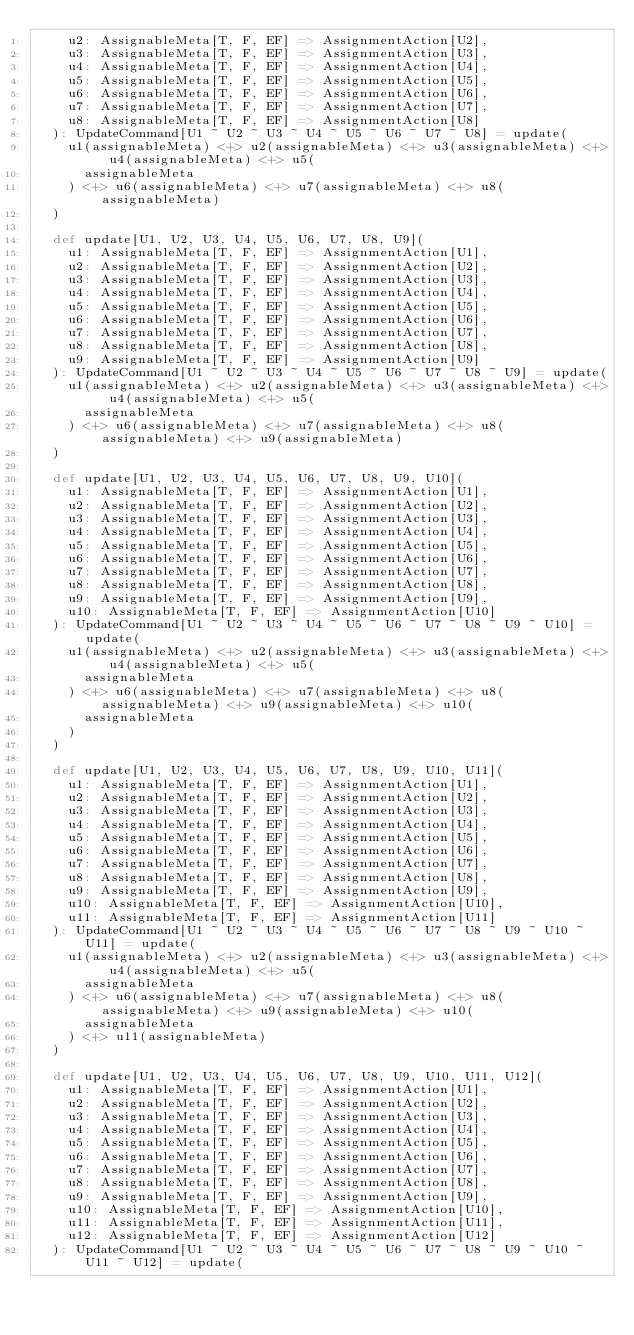Convert code to text. <code><loc_0><loc_0><loc_500><loc_500><_Scala_>    u2: AssignableMeta[T, F, EF] => AssignmentAction[U2],
    u3: AssignableMeta[T, F, EF] => AssignmentAction[U3],
    u4: AssignableMeta[T, F, EF] => AssignmentAction[U4],
    u5: AssignableMeta[T, F, EF] => AssignmentAction[U5],
    u6: AssignableMeta[T, F, EF] => AssignmentAction[U6],
    u7: AssignableMeta[T, F, EF] => AssignmentAction[U7],
    u8: AssignableMeta[T, F, EF] => AssignmentAction[U8]
  ): UpdateCommand[U1 ~ U2 ~ U3 ~ U4 ~ U5 ~ U6 ~ U7 ~ U8] = update(
    u1(assignableMeta) <+> u2(assignableMeta) <+> u3(assignableMeta) <+> u4(assignableMeta) <+> u5(
      assignableMeta
    ) <+> u6(assignableMeta) <+> u7(assignableMeta) <+> u8(assignableMeta)
  )

  def update[U1, U2, U3, U4, U5, U6, U7, U8, U9](
    u1: AssignableMeta[T, F, EF] => AssignmentAction[U1],
    u2: AssignableMeta[T, F, EF] => AssignmentAction[U2],
    u3: AssignableMeta[T, F, EF] => AssignmentAction[U3],
    u4: AssignableMeta[T, F, EF] => AssignmentAction[U4],
    u5: AssignableMeta[T, F, EF] => AssignmentAction[U5],
    u6: AssignableMeta[T, F, EF] => AssignmentAction[U6],
    u7: AssignableMeta[T, F, EF] => AssignmentAction[U7],
    u8: AssignableMeta[T, F, EF] => AssignmentAction[U8],
    u9: AssignableMeta[T, F, EF] => AssignmentAction[U9]
  ): UpdateCommand[U1 ~ U2 ~ U3 ~ U4 ~ U5 ~ U6 ~ U7 ~ U8 ~ U9] = update(
    u1(assignableMeta) <+> u2(assignableMeta) <+> u3(assignableMeta) <+> u4(assignableMeta) <+> u5(
      assignableMeta
    ) <+> u6(assignableMeta) <+> u7(assignableMeta) <+> u8(assignableMeta) <+> u9(assignableMeta)
  )

  def update[U1, U2, U3, U4, U5, U6, U7, U8, U9, U10](
    u1: AssignableMeta[T, F, EF] => AssignmentAction[U1],
    u2: AssignableMeta[T, F, EF] => AssignmentAction[U2],
    u3: AssignableMeta[T, F, EF] => AssignmentAction[U3],
    u4: AssignableMeta[T, F, EF] => AssignmentAction[U4],
    u5: AssignableMeta[T, F, EF] => AssignmentAction[U5],
    u6: AssignableMeta[T, F, EF] => AssignmentAction[U6],
    u7: AssignableMeta[T, F, EF] => AssignmentAction[U7],
    u8: AssignableMeta[T, F, EF] => AssignmentAction[U8],
    u9: AssignableMeta[T, F, EF] => AssignmentAction[U9],
    u10: AssignableMeta[T, F, EF] => AssignmentAction[U10]
  ): UpdateCommand[U1 ~ U2 ~ U3 ~ U4 ~ U5 ~ U6 ~ U7 ~ U8 ~ U9 ~ U10] = update(
    u1(assignableMeta) <+> u2(assignableMeta) <+> u3(assignableMeta) <+> u4(assignableMeta) <+> u5(
      assignableMeta
    ) <+> u6(assignableMeta) <+> u7(assignableMeta) <+> u8(assignableMeta) <+> u9(assignableMeta) <+> u10(
      assignableMeta
    )
  )

  def update[U1, U2, U3, U4, U5, U6, U7, U8, U9, U10, U11](
    u1: AssignableMeta[T, F, EF] => AssignmentAction[U1],
    u2: AssignableMeta[T, F, EF] => AssignmentAction[U2],
    u3: AssignableMeta[T, F, EF] => AssignmentAction[U3],
    u4: AssignableMeta[T, F, EF] => AssignmentAction[U4],
    u5: AssignableMeta[T, F, EF] => AssignmentAction[U5],
    u6: AssignableMeta[T, F, EF] => AssignmentAction[U6],
    u7: AssignableMeta[T, F, EF] => AssignmentAction[U7],
    u8: AssignableMeta[T, F, EF] => AssignmentAction[U8],
    u9: AssignableMeta[T, F, EF] => AssignmentAction[U9],
    u10: AssignableMeta[T, F, EF] => AssignmentAction[U10],
    u11: AssignableMeta[T, F, EF] => AssignmentAction[U11]
  ): UpdateCommand[U1 ~ U2 ~ U3 ~ U4 ~ U5 ~ U6 ~ U7 ~ U8 ~ U9 ~ U10 ~ U11] = update(
    u1(assignableMeta) <+> u2(assignableMeta) <+> u3(assignableMeta) <+> u4(assignableMeta) <+> u5(
      assignableMeta
    ) <+> u6(assignableMeta) <+> u7(assignableMeta) <+> u8(assignableMeta) <+> u9(assignableMeta) <+> u10(
      assignableMeta
    ) <+> u11(assignableMeta)
  )

  def update[U1, U2, U3, U4, U5, U6, U7, U8, U9, U10, U11, U12](
    u1: AssignableMeta[T, F, EF] => AssignmentAction[U1],
    u2: AssignableMeta[T, F, EF] => AssignmentAction[U2],
    u3: AssignableMeta[T, F, EF] => AssignmentAction[U3],
    u4: AssignableMeta[T, F, EF] => AssignmentAction[U4],
    u5: AssignableMeta[T, F, EF] => AssignmentAction[U5],
    u6: AssignableMeta[T, F, EF] => AssignmentAction[U6],
    u7: AssignableMeta[T, F, EF] => AssignmentAction[U7],
    u8: AssignableMeta[T, F, EF] => AssignmentAction[U8],
    u9: AssignableMeta[T, F, EF] => AssignmentAction[U9],
    u10: AssignableMeta[T, F, EF] => AssignmentAction[U10],
    u11: AssignableMeta[T, F, EF] => AssignmentAction[U11],
    u12: AssignableMeta[T, F, EF] => AssignmentAction[U12]
  ): UpdateCommand[U1 ~ U2 ~ U3 ~ U4 ~ U5 ~ U6 ~ U7 ~ U8 ~ U9 ~ U10 ~ U11 ~ U12] = update(</code> 